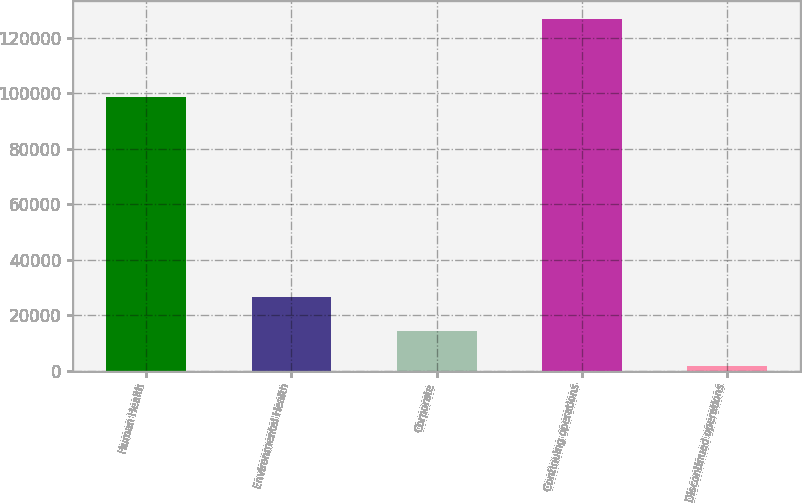<chart> <loc_0><loc_0><loc_500><loc_500><bar_chart><fcel>Human Health<fcel>Environmental Health<fcel>Corporate<fcel>Continuing operations<fcel>Discontinued operations<nl><fcel>98582<fcel>26647.8<fcel>14118.9<fcel>126879<fcel>1590<nl></chart> 